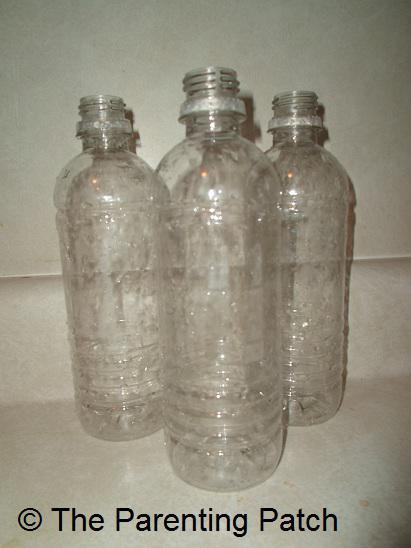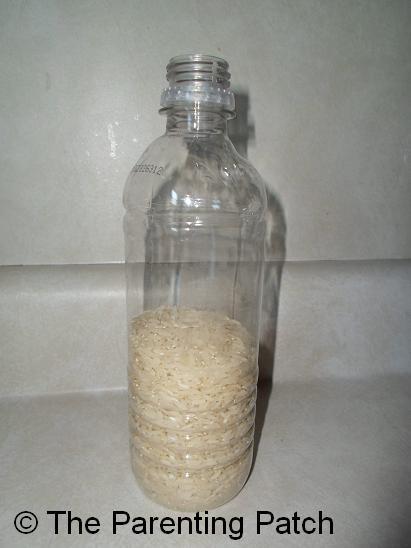The first image is the image on the left, the second image is the image on the right. Assess this claim about the two images: "In one image, three empty bottles with no caps and glistening from a light source, are sitting in a triangle shaped arrangement.". Correct or not? Answer yes or no. Yes. The first image is the image on the left, the second image is the image on the right. Considering the images on both sides, is "None of the bottles have labels." valid? Answer yes or no. Yes. 